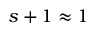<formula> <loc_0><loc_0><loc_500><loc_500>s + 1 \approx 1</formula> 